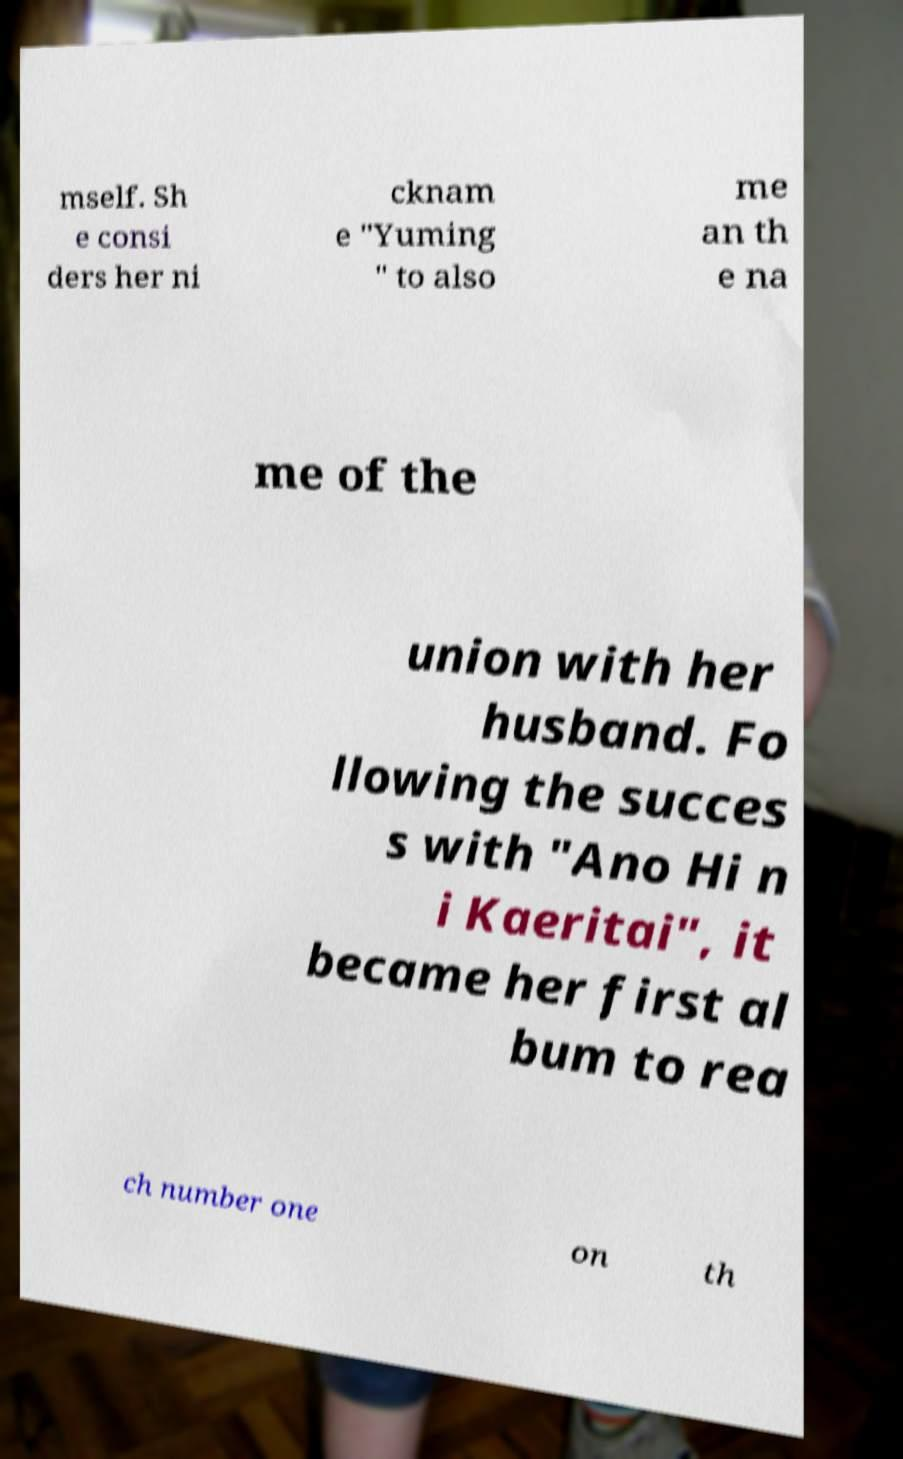Please identify and transcribe the text found in this image. mself. Sh e consi ders her ni cknam e "Yuming " to also me an th e na me of the union with her husband. Fo llowing the succes s with "Ano Hi n i Kaeritai", it became her first al bum to rea ch number one on th 